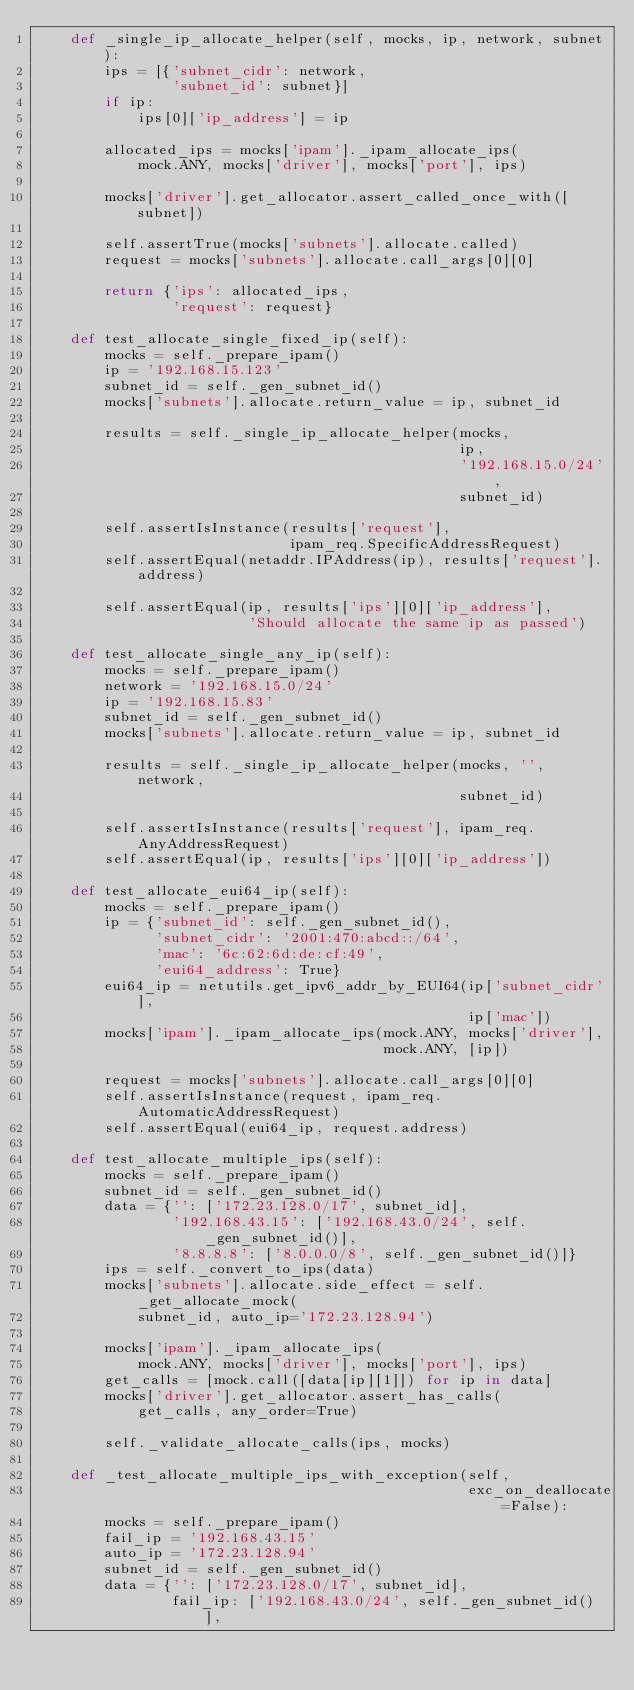<code> <loc_0><loc_0><loc_500><loc_500><_Python_>    def _single_ip_allocate_helper(self, mocks, ip, network, subnet):
        ips = [{'subnet_cidr': network,
                'subnet_id': subnet}]
        if ip:
            ips[0]['ip_address'] = ip

        allocated_ips = mocks['ipam']._ipam_allocate_ips(
            mock.ANY, mocks['driver'], mocks['port'], ips)

        mocks['driver'].get_allocator.assert_called_once_with([subnet])

        self.assertTrue(mocks['subnets'].allocate.called)
        request = mocks['subnets'].allocate.call_args[0][0]

        return {'ips': allocated_ips,
                'request': request}

    def test_allocate_single_fixed_ip(self):
        mocks = self._prepare_ipam()
        ip = '192.168.15.123'
        subnet_id = self._gen_subnet_id()
        mocks['subnets'].allocate.return_value = ip, subnet_id

        results = self._single_ip_allocate_helper(mocks,
                                                  ip,
                                                  '192.168.15.0/24',
                                                  subnet_id)

        self.assertIsInstance(results['request'],
                              ipam_req.SpecificAddressRequest)
        self.assertEqual(netaddr.IPAddress(ip), results['request'].address)

        self.assertEqual(ip, results['ips'][0]['ip_address'],
                         'Should allocate the same ip as passed')

    def test_allocate_single_any_ip(self):
        mocks = self._prepare_ipam()
        network = '192.168.15.0/24'
        ip = '192.168.15.83'
        subnet_id = self._gen_subnet_id()
        mocks['subnets'].allocate.return_value = ip, subnet_id

        results = self._single_ip_allocate_helper(mocks, '', network,
                                                  subnet_id)

        self.assertIsInstance(results['request'], ipam_req.AnyAddressRequest)
        self.assertEqual(ip, results['ips'][0]['ip_address'])

    def test_allocate_eui64_ip(self):
        mocks = self._prepare_ipam()
        ip = {'subnet_id': self._gen_subnet_id(),
              'subnet_cidr': '2001:470:abcd::/64',
              'mac': '6c:62:6d:de:cf:49',
              'eui64_address': True}
        eui64_ip = netutils.get_ipv6_addr_by_EUI64(ip['subnet_cidr'],
                                                   ip['mac'])
        mocks['ipam']._ipam_allocate_ips(mock.ANY, mocks['driver'],
                                         mock.ANY, [ip])

        request = mocks['subnets'].allocate.call_args[0][0]
        self.assertIsInstance(request, ipam_req.AutomaticAddressRequest)
        self.assertEqual(eui64_ip, request.address)

    def test_allocate_multiple_ips(self):
        mocks = self._prepare_ipam()
        subnet_id = self._gen_subnet_id()
        data = {'': ['172.23.128.0/17', subnet_id],
                '192.168.43.15': ['192.168.43.0/24', self._gen_subnet_id()],
                '8.8.8.8': ['8.0.0.0/8', self._gen_subnet_id()]}
        ips = self._convert_to_ips(data)
        mocks['subnets'].allocate.side_effect = self._get_allocate_mock(
            subnet_id, auto_ip='172.23.128.94')

        mocks['ipam']._ipam_allocate_ips(
            mock.ANY, mocks['driver'], mocks['port'], ips)
        get_calls = [mock.call([data[ip][1]]) for ip in data]
        mocks['driver'].get_allocator.assert_has_calls(
            get_calls, any_order=True)

        self._validate_allocate_calls(ips, mocks)

    def _test_allocate_multiple_ips_with_exception(self,
                                                   exc_on_deallocate=False):
        mocks = self._prepare_ipam()
        fail_ip = '192.168.43.15'
        auto_ip = '172.23.128.94'
        subnet_id = self._gen_subnet_id()
        data = {'': ['172.23.128.0/17', subnet_id],
                fail_ip: ['192.168.43.0/24', self._gen_subnet_id()],</code> 